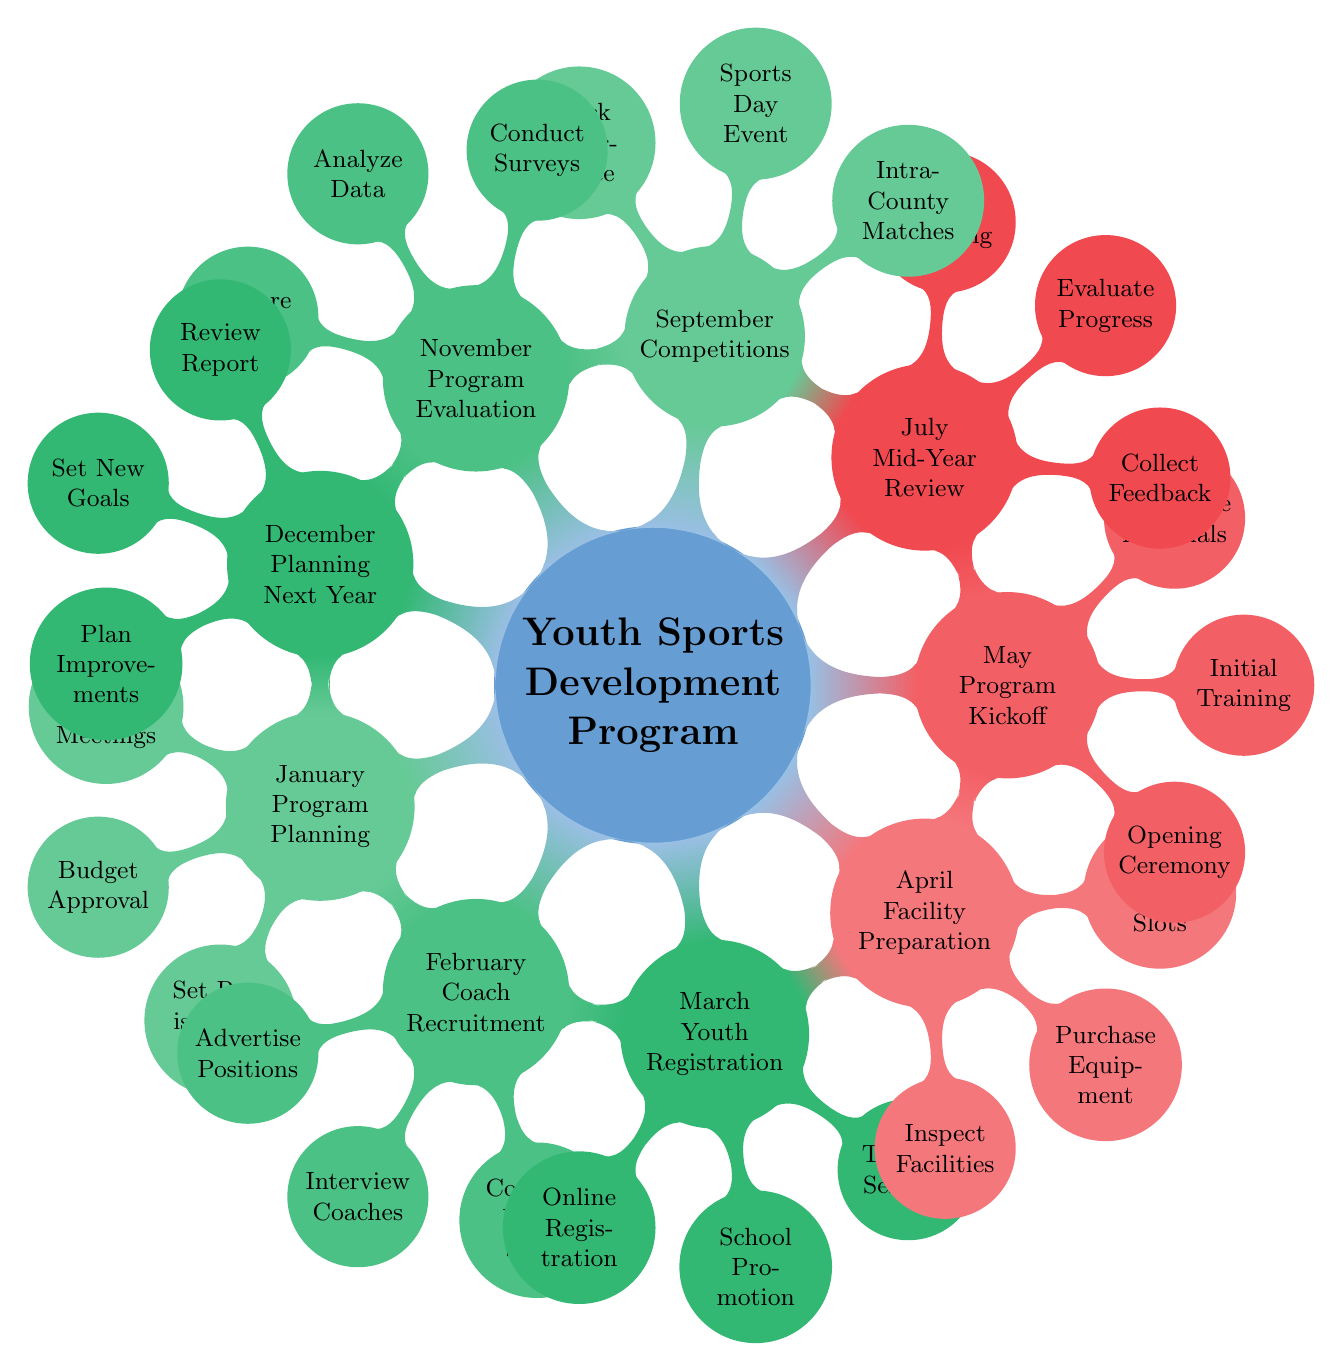What is the first milestone in the program? The first milestone, as shown in the diagram, is "Program Planning," which takes place in January. This is the starting point of the timeline, indicating that the program begins here.
Answer: Program Planning How many activities are listed under the "January" milestone? In the diagram, there are three activities listed under "Program Planning" in January: Community Meetings, Budget Approval, and Set Registration Dates. By counting these activities, we can ascertain the total for this month.
Answer: 3 Which month focuses on "Competitions"? The diagram indicates that "Competitions" is the focus in September. This is clearly labeled as a milestone for that month, outlining activities related to sports events and performance tracking.
Answer: September What activity is scheduled for July? The diagram shows that "Mid-Year Review" is the main activity scheduled for July. Under this milestone, the activities include Collect Feedback, Evaluate Progress, and Adjust Training.
Answer: Mid-Year Review What is the last activity listed for December? The last activity indicated in the diagram for December is "Plan Improvements." This concludes the year’s activities and suggests preparation for the upcoming year.
Answer: Plan Improvements Which two milestones are connected directly in terms of progress evaluation? The milestones "July" (Mid-Year Review) and "November" (Program Evaluation) are directly connected in terms of progress evaluation. Both months focus on assessing and improving the program’s effectiveness based on collected data and feedback.
Answer: July and November How many nodes are there in total in the diagram? By counting the main milestones and their associated activities, we find a total of 24 nodes in the diagram, consisting of the 8 months along with their respective activities.
Answer: 24 What is the primary goal for May? The primary goal in May, as represented in the diagram, is to kick off the program, indicated by the activities of Opening Ceremony, Initial Training, and Distributing Materials. This marks the beginning of active program operations.
Answer: Program Kickoff Which month involves "School Promotion"? The activity "School Promotion" is scheduled for March, as part of the Youth Registration process. This shows that efforts to encourage youth registration occur during this month.
Answer: March 